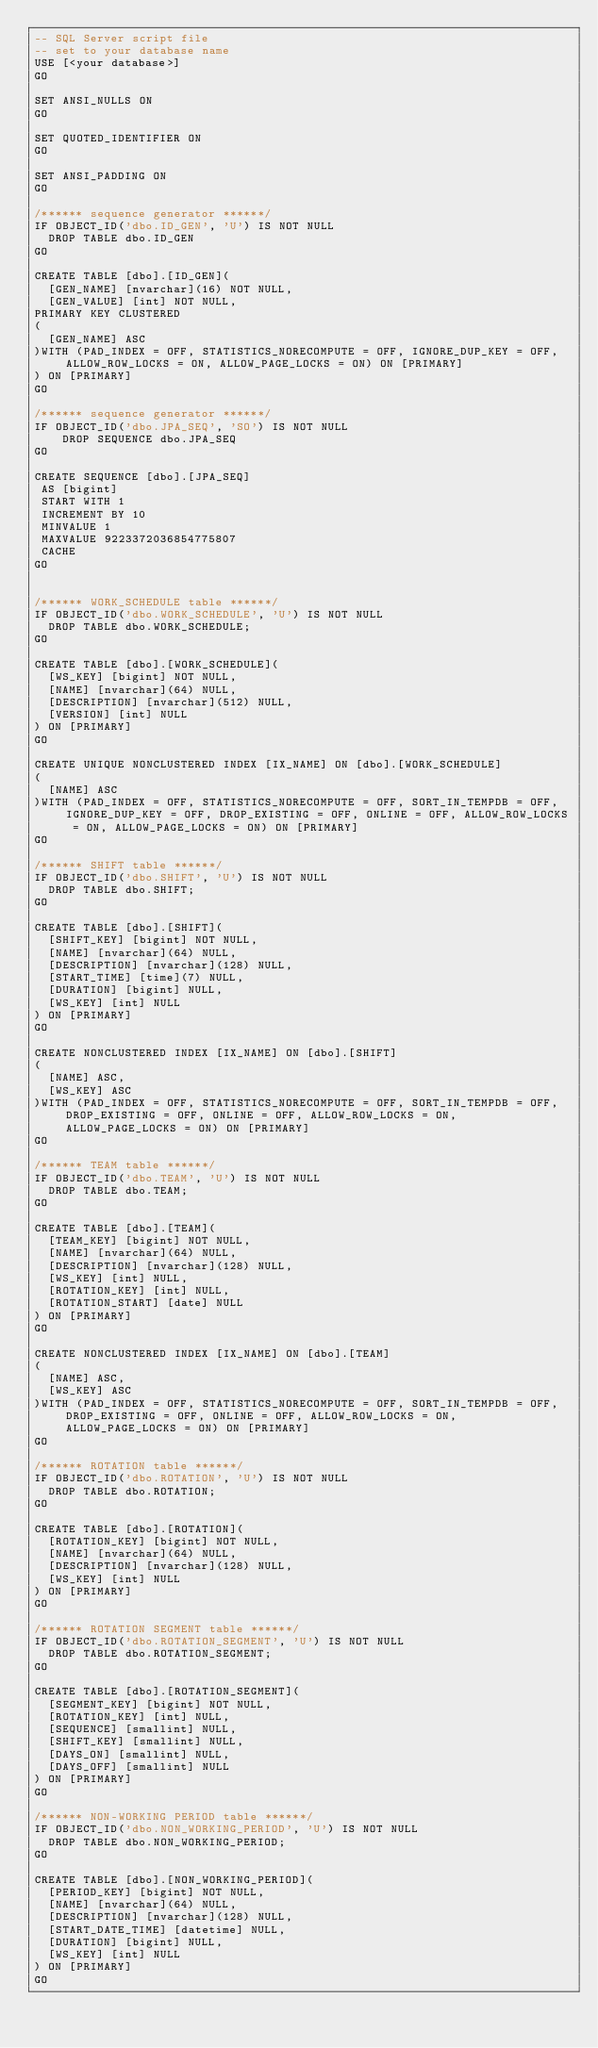<code> <loc_0><loc_0><loc_500><loc_500><_SQL_>-- SQL Server script file
-- set to your database name
USE [<your database>]
GO

SET ANSI_NULLS ON
GO

SET QUOTED_IDENTIFIER ON
GO

SET ANSI_PADDING ON
GO

/****** sequence generator ******/
IF OBJECT_ID('dbo.ID_GEN', 'U') IS NOT NULL 
  DROP TABLE dbo.ID_GEN
GO

CREATE TABLE [dbo].[ID_GEN](
	[GEN_NAME] [nvarchar](16) NOT NULL,
	[GEN_VALUE] [int] NOT NULL,
PRIMARY KEY CLUSTERED 
(
	[GEN_NAME] ASC
)WITH (PAD_INDEX = OFF, STATISTICS_NORECOMPUTE = OFF, IGNORE_DUP_KEY = OFF, ALLOW_ROW_LOCKS = ON, ALLOW_PAGE_LOCKS = ON) ON [PRIMARY]
) ON [PRIMARY]
GO

/****** sequence generator ******/
IF OBJECT_ID('dbo.JPA_SEQ', 'SO') IS NOT NULL 
    DROP SEQUENCE dbo.JPA_SEQ
GO

CREATE SEQUENCE [dbo].[JPA_SEQ] 
 AS [bigint]
 START WITH 1
 INCREMENT BY 10
 MINVALUE 1
 MAXVALUE 9223372036854775807
 CACHE 
GO


/****** WORK_SCHEDULE table ******/
IF OBJECT_ID('dbo.WORK_SCHEDULE', 'U') IS NOT NULL 
  DROP TABLE dbo.WORK_SCHEDULE; 
GO

CREATE TABLE [dbo].[WORK_SCHEDULE](
	[WS_KEY] [bigint] NOT NULL,
	[NAME] [nvarchar](64) NULL,
	[DESCRIPTION] [nvarchar](512) NULL,
	[VERSION] [int] NULL
) ON [PRIMARY]
GO

CREATE UNIQUE NONCLUSTERED INDEX [IX_NAME] ON [dbo].[WORK_SCHEDULE]
(
	[NAME] ASC
)WITH (PAD_INDEX = OFF, STATISTICS_NORECOMPUTE = OFF, SORT_IN_TEMPDB = OFF, IGNORE_DUP_KEY = OFF, DROP_EXISTING = OFF, ONLINE = OFF, ALLOW_ROW_LOCKS = ON, ALLOW_PAGE_LOCKS = ON) ON [PRIMARY]
GO

/****** SHIFT table ******/
IF OBJECT_ID('dbo.SHIFT', 'U') IS NOT NULL 
  DROP TABLE dbo.SHIFT; 
GO

CREATE TABLE [dbo].[SHIFT](
	[SHIFT_KEY] [bigint] NOT NULL,
	[NAME] [nvarchar](64) NULL,
	[DESCRIPTION] [nvarchar](128) NULL,
	[START_TIME] [time](7) NULL,
	[DURATION] [bigint] NULL,
	[WS_KEY] [int] NULL
) ON [PRIMARY]
GO

CREATE NONCLUSTERED INDEX [IX_NAME] ON [dbo].[SHIFT]
(
	[NAME] ASC,
	[WS_KEY] ASC
)WITH (PAD_INDEX = OFF, STATISTICS_NORECOMPUTE = OFF, SORT_IN_TEMPDB = OFF, DROP_EXISTING = OFF, ONLINE = OFF, ALLOW_ROW_LOCKS = ON, ALLOW_PAGE_LOCKS = ON) ON [PRIMARY]
GO

/****** TEAM table ******/
IF OBJECT_ID('dbo.TEAM', 'U') IS NOT NULL 
  DROP TABLE dbo.TEAM; 
GO

CREATE TABLE [dbo].[TEAM](
	[TEAM_KEY] [bigint] NOT NULL,
	[NAME] [nvarchar](64) NULL,
	[DESCRIPTION] [nvarchar](128) NULL,
	[WS_KEY] [int] NULL,
	[ROTATION_KEY] [int] NULL,
	[ROTATION_START] [date] NULL
) ON [PRIMARY]
GO

CREATE NONCLUSTERED INDEX [IX_NAME] ON [dbo].[TEAM]
(
	[NAME] ASC,
	[WS_KEY] ASC
)WITH (PAD_INDEX = OFF, STATISTICS_NORECOMPUTE = OFF, SORT_IN_TEMPDB = OFF, DROP_EXISTING = OFF, ONLINE = OFF, ALLOW_ROW_LOCKS = ON, ALLOW_PAGE_LOCKS = ON) ON [PRIMARY]
GO

/****** ROTATION table ******/
IF OBJECT_ID('dbo.ROTATION', 'U') IS NOT NULL 
  DROP TABLE dbo.ROTATION; 
GO

CREATE TABLE [dbo].[ROTATION](
	[ROTATION_KEY] [bigint] NOT NULL,
	[NAME] [nvarchar](64) NULL,
	[DESCRIPTION] [nvarchar](128) NULL,
	[WS_KEY] [int] NULL
) ON [PRIMARY]
GO

/****** ROTATION SEGMENT table ******/
IF OBJECT_ID('dbo.ROTATION_SEGMENT', 'U') IS NOT NULL 
  DROP TABLE dbo.ROTATION_SEGMENT; 
GO

CREATE TABLE [dbo].[ROTATION_SEGMENT](
	[SEGMENT_KEY] [bigint] NOT NULL,
	[ROTATION_KEY] [int] NULL,
	[SEQUENCE] [smallint] NULL,
	[SHIFT_KEY] [smallint] NULL,
	[DAYS_ON] [smallint] NULL,
	[DAYS_OFF] [smallint] NULL
) ON [PRIMARY]
GO

/****** NON-WORKING PERIOD table ******/
IF OBJECT_ID('dbo.NON_WORKING_PERIOD', 'U') IS NOT NULL 
  DROP TABLE dbo.NON_WORKING_PERIOD; 
GO

CREATE TABLE [dbo].[NON_WORKING_PERIOD](
	[PERIOD_KEY] [bigint] NOT NULL,
	[NAME] [nvarchar](64) NULL,
	[DESCRIPTION] [nvarchar](128) NULL,
	[START_DATE_TIME] [datetime] NULL,
	[DURATION] [bigint] NULL,
	[WS_KEY] [int] NULL
) ON [PRIMARY]
GO

</code> 